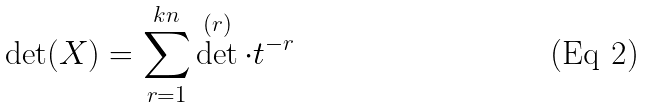Convert formula to latex. <formula><loc_0><loc_0><loc_500><loc_500>\det ( X ) = \sum _ { r = 1 } ^ { k n } \det ^ { ( r ) } \cdot t ^ { - r }</formula> 